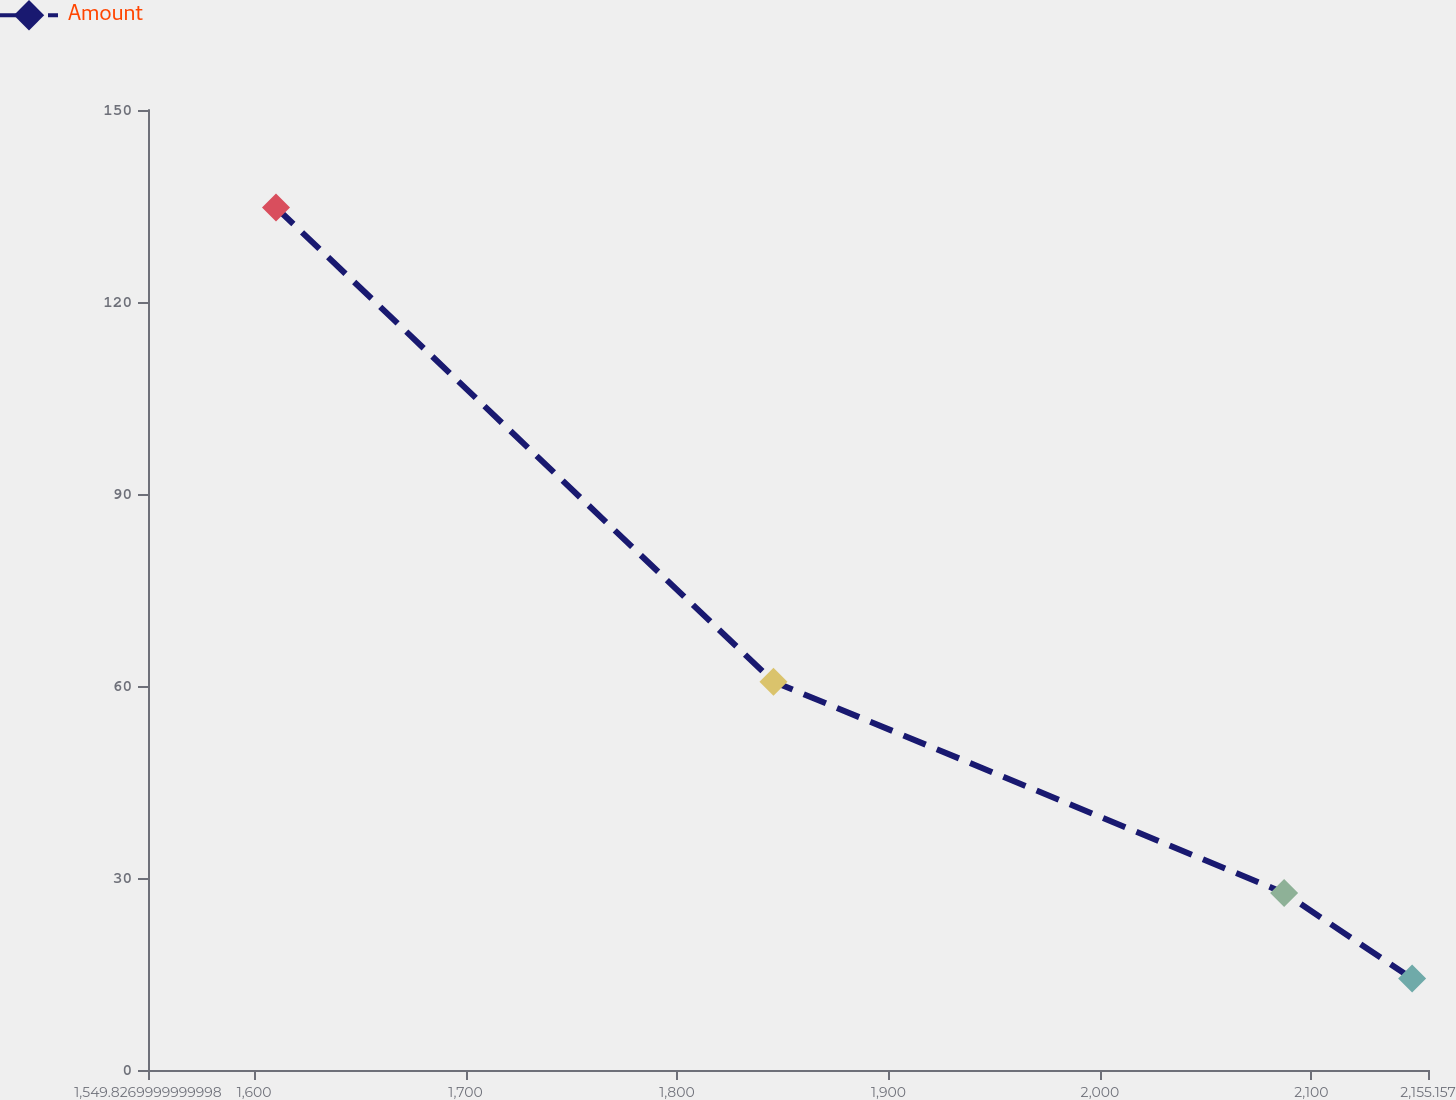Convert chart. <chart><loc_0><loc_0><loc_500><loc_500><line_chart><ecel><fcel>Amount<nl><fcel>1610.36<fcel>134.77<nl><fcel>1845.62<fcel>60.68<nl><fcel>2087.12<fcel>27.67<nl><fcel>2147.65<fcel>14.28<nl><fcel>2215.69<fcel>0.89<nl></chart> 